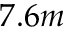Convert formula to latex. <formula><loc_0><loc_0><loc_500><loc_500>7 . 6 m</formula> 